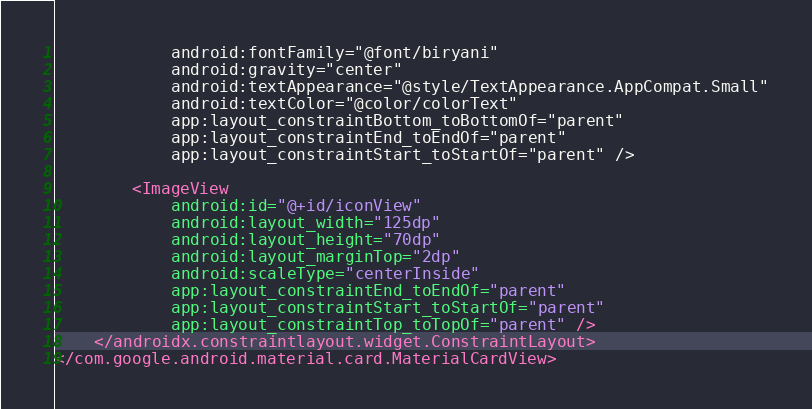Convert code to text. <code><loc_0><loc_0><loc_500><loc_500><_XML_>            android:fontFamily="@font/biryani"
            android:gravity="center"
            android:textAppearance="@style/TextAppearance.AppCompat.Small"
            android:textColor="@color/colorText"
            app:layout_constraintBottom_toBottomOf="parent"
            app:layout_constraintEnd_toEndOf="parent"
            app:layout_constraintStart_toStartOf="parent" />

        <ImageView
            android:id="@+id/iconView"
            android:layout_width="125dp"
            android:layout_height="70dp"
            android:layout_marginTop="2dp"
            android:scaleType="centerInside"
            app:layout_constraintEnd_toEndOf="parent"
            app:layout_constraintStart_toStartOf="parent"
            app:layout_constraintTop_toTopOf="parent" />
    </androidx.constraintlayout.widget.ConstraintLayout>
</com.google.android.material.card.MaterialCardView></code> 